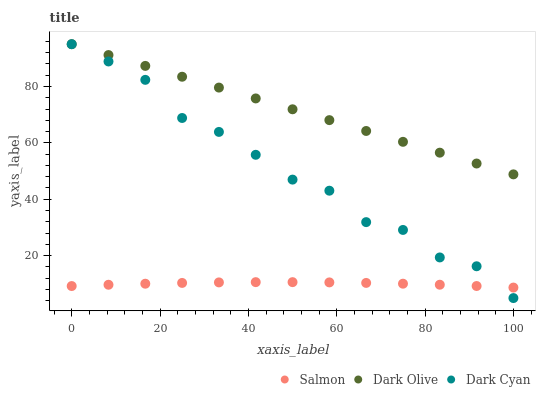Does Salmon have the minimum area under the curve?
Answer yes or no. Yes. Does Dark Olive have the maximum area under the curve?
Answer yes or no. Yes. Does Dark Olive have the minimum area under the curve?
Answer yes or no. No. Does Salmon have the maximum area under the curve?
Answer yes or no. No. Is Dark Olive the smoothest?
Answer yes or no. Yes. Is Dark Cyan the roughest?
Answer yes or no. Yes. Is Salmon the smoothest?
Answer yes or no. No. Is Salmon the roughest?
Answer yes or no. No. Does Dark Cyan have the lowest value?
Answer yes or no. Yes. Does Salmon have the lowest value?
Answer yes or no. No. Does Dark Olive have the highest value?
Answer yes or no. Yes. Does Salmon have the highest value?
Answer yes or no. No. Is Salmon less than Dark Olive?
Answer yes or no. Yes. Is Dark Olive greater than Salmon?
Answer yes or no. Yes. Does Salmon intersect Dark Cyan?
Answer yes or no. Yes. Is Salmon less than Dark Cyan?
Answer yes or no. No. Is Salmon greater than Dark Cyan?
Answer yes or no. No. Does Salmon intersect Dark Olive?
Answer yes or no. No. 